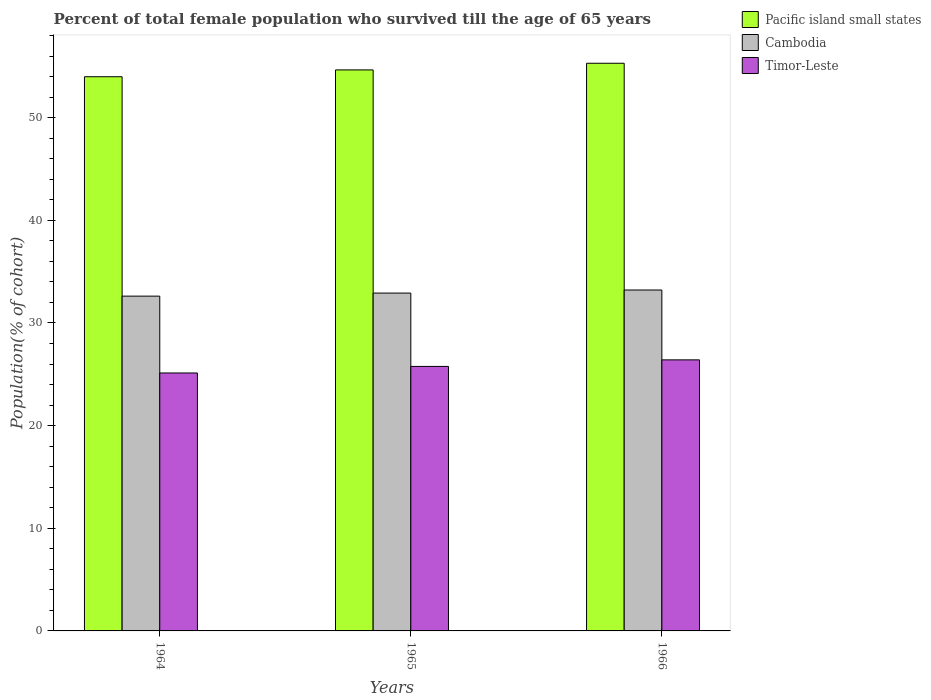How many different coloured bars are there?
Your answer should be compact. 3. How many groups of bars are there?
Make the answer very short. 3. Are the number of bars on each tick of the X-axis equal?
Give a very brief answer. Yes. How many bars are there on the 2nd tick from the left?
Make the answer very short. 3. What is the label of the 2nd group of bars from the left?
Offer a very short reply. 1965. What is the percentage of total female population who survived till the age of 65 years in Pacific island small states in 1964?
Provide a succinct answer. 53.99. Across all years, what is the maximum percentage of total female population who survived till the age of 65 years in Pacific island small states?
Your answer should be very brief. 55.3. Across all years, what is the minimum percentage of total female population who survived till the age of 65 years in Pacific island small states?
Your response must be concise. 53.99. In which year was the percentage of total female population who survived till the age of 65 years in Pacific island small states maximum?
Provide a succinct answer. 1966. In which year was the percentage of total female population who survived till the age of 65 years in Cambodia minimum?
Your answer should be compact. 1964. What is the total percentage of total female population who survived till the age of 65 years in Pacific island small states in the graph?
Your answer should be very brief. 163.94. What is the difference between the percentage of total female population who survived till the age of 65 years in Timor-Leste in 1965 and that in 1966?
Offer a very short reply. -0.64. What is the difference between the percentage of total female population who survived till the age of 65 years in Pacific island small states in 1965 and the percentage of total female population who survived till the age of 65 years in Cambodia in 1966?
Give a very brief answer. 21.44. What is the average percentage of total female population who survived till the age of 65 years in Timor-Leste per year?
Provide a short and direct response. 25.77. In the year 1966, what is the difference between the percentage of total female population who survived till the age of 65 years in Cambodia and percentage of total female population who survived till the age of 65 years in Pacific island small states?
Offer a terse response. -22.09. In how many years, is the percentage of total female population who survived till the age of 65 years in Timor-Leste greater than 44 %?
Your answer should be very brief. 0. What is the ratio of the percentage of total female population who survived till the age of 65 years in Cambodia in 1964 to that in 1965?
Your answer should be compact. 0.99. Is the percentage of total female population who survived till the age of 65 years in Cambodia in 1964 less than that in 1966?
Your answer should be very brief. Yes. What is the difference between the highest and the second highest percentage of total female population who survived till the age of 65 years in Cambodia?
Offer a terse response. 0.3. What is the difference between the highest and the lowest percentage of total female population who survived till the age of 65 years in Cambodia?
Give a very brief answer. 0.6. In how many years, is the percentage of total female population who survived till the age of 65 years in Cambodia greater than the average percentage of total female population who survived till the age of 65 years in Cambodia taken over all years?
Make the answer very short. 2. Is the sum of the percentage of total female population who survived till the age of 65 years in Cambodia in 1964 and 1965 greater than the maximum percentage of total female population who survived till the age of 65 years in Timor-Leste across all years?
Provide a short and direct response. Yes. What does the 3rd bar from the left in 1966 represents?
Provide a short and direct response. Timor-Leste. What does the 2nd bar from the right in 1966 represents?
Give a very brief answer. Cambodia. How many years are there in the graph?
Provide a short and direct response. 3. Does the graph contain any zero values?
Provide a succinct answer. No. Does the graph contain grids?
Provide a succinct answer. No. How many legend labels are there?
Give a very brief answer. 3. How are the legend labels stacked?
Offer a terse response. Vertical. What is the title of the graph?
Make the answer very short. Percent of total female population who survived till the age of 65 years. Does "Uruguay" appear as one of the legend labels in the graph?
Give a very brief answer. No. What is the label or title of the Y-axis?
Provide a short and direct response. Population(% of cohort). What is the Population(% of cohort) of Pacific island small states in 1964?
Provide a short and direct response. 53.99. What is the Population(% of cohort) in Cambodia in 1964?
Keep it short and to the point. 32.61. What is the Population(% of cohort) in Timor-Leste in 1964?
Keep it short and to the point. 25.13. What is the Population(% of cohort) in Pacific island small states in 1965?
Provide a short and direct response. 54.65. What is the Population(% of cohort) of Cambodia in 1965?
Offer a terse response. 32.91. What is the Population(% of cohort) in Timor-Leste in 1965?
Ensure brevity in your answer.  25.77. What is the Population(% of cohort) in Pacific island small states in 1966?
Provide a short and direct response. 55.3. What is the Population(% of cohort) in Cambodia in 1966?
Your response must be concise. 33.21. What is the Population(% of cohort) in Timor-Leste in 1966?
Offer a very short reply. 26.41. Across all years, what is the maximum Population(% of cohort) of Pacific island small states?
Make the answer very short. 55.3. Across all years, what is the maximum Population(% of cohort) in Cambodia?
Offer a very short reply. 33.21. Across all years, what is the maximum Population(% of cohort) of Timor-Leste?
Your answer should be compact. 26.41. Across all years, what is the minimum Population(% of cohort) of Pacific island small states?
Provide a short and direct response. 53.99. Across all years, what is the minimum Population(% of cohort) of Cambodia?
Offer a very short reply. 32.61. Across all years, what is the minimum Population(% of cohort) of Timor-Leste?
Make the answer very short. 25.13. What is the total Population(% of cohort) in Pacific island small states in the graph?
Ensure brevity in your answer.  163.94. What is the total Population(% of cohort) of Cambodia in the graph?
Provide a succinct answer. 98.74. What is the total Population(% of cohort) in Timor-Leste in the graph?
Your response must be concise. 77.3. What is the difference between the Population(% of cohort) of Pacific island small states in 1964 and that in 1965?
Offer a terse response. -0.66. What is the difference between the Population(% of cohort) of Cambodia in 1964 and that in 1965?
Offer a terse response. -0.3. What is the difference between the Population(% of cohort) of Timor-Leste in 1964 and that in 1965?
Ensure brevity in your answer.  -0.64. What is the difference between the Population(% of cohort) of Pacific island small states in 1964 and that in 1966?
Give a very brief answer. -1.31. What is the difference between the Population(% of cohort) of Cambodia in 1964 and that in 1966?
Your answer should be compact. -0.6. What is the difference between the Population(% of cohort) of Timor-Leste in 1964 and that in 1966?
Provide a short and direct response. -1.28. What is the difference between the Population(% of cohort) in Pacific island small states in 1965 and that in 1966?
Ensure brevity in your answer.  -0.65. What is the difference between the Population(% of cohort) of Cambodia in 1965 and that in 1966?
Offer a very short reply. -0.3. What is the difference between the Population(% of cohort) in Timor-Leste in 1965 and that in 1966?
Your answer should be very brief. -0.64. What is the difference between the Population(% of cohort) in Pacific island small states in 1964 and the Population(% of cohort) in Cambodia in 1965?
Ensure brevity in your answer.  21.08. What is the difference between the Population(% of cohort) of Pacific island small states in 1964 and the Population(% of cohort) of Timor-Leste in 1965?
Your response must be concise. 28.22. What is the difference between the Population(% of cohort) of Cambodia in 1964 and the Population(% of cohort) of Timor-Leste in 1965?
Give a very brief answer. 6.85. What is the difference between the Population(% of cohort) of Pacific island small states in 1964 and the Population(% of cohort) of Cambodia in 1966?
Your response must be concise. 20.78. What is the difference between the Population(% of cohort) of Pacific island small states in 1964 and the Population(% of cohort) of Timor-Leste in 1966?
Ensure brevity in your answer.  27.58. What is the difference between the Population(% of cohort) of Cambodia in 1964 and the Population(% of cohort) of Timor-Leste in 1966?
Give a very brief answer. 6.21. What is the difference between the Population(% of cohort) of Pacific island small states in 1965 and the Population(% of cohort) of Cambodia in 1966?
Your response must be concise. 21.44. What is the difference between the Population(% of cohort) in Pacific island small states in 1965 and the Population(% of cohort) in Timor-Leste in 1966?
Your response must be concise. 28.25. What is the difference between the Population(% of cohort) of Cambodia in 1965 and the Population(% of cohort) of Timor-Leste in 1966?
Keep it short and to the point. 6.51. What is the average Population(% of cohort) of Pacific island small states per year?
Provide a succinct answer. 54.65. What is the average Population(% of cohort) in Cambodia per year?
Your answer should be very brief. 32.91. What is the average Population(% of cohort) of Timor-Leste per year?
Provide a short and direct response. 25.77. In the year 1964, what is the difference between the Population(% of cohort) in Pacific island small states and Population(% of cohort) in Cambodia?
Your answer should be very brief. 21.38. In the year 1964, what is the difference between the Population(% of cohort) of Pacific island small states and Population(% of cohort) of Timor-Leste?
Offer a terse response. 28.86. In the year 1964, what is the difference between the Population(% of cohort) of Cambodia and Population(% of cohort) of Timor-Leste?
Keep it short and to the point. 7.49. In the year 1965, what is the difference between the Population(% of cohort) in Pacific island small states and Population(% of cohort) in Cambodia?
Provide a short and direct response. 21.74. In the year 1965, what is the difference between the Population(% of cohort) in Pacific island small states and Population(% of cohort) in Timor-Leste?
Make the answer very short. 28.89. In the year 1965, what is the difference between the Population(% of cohort) in Cambodia and Population(% of cohort) in Timor-Leste?
Provide a short and direct response. 7.14. In the year 1966, what is the difference between the Population(% of cohort) of Pacific island small states and Population(% of cohort) of Cambodia?
Your response must be concise. 22.09. In the year 1966, what is the difference between the Population(% of cohort) of Pacific island small states and Population(% of cohort) of Timor-Leste?
Provide a succinct answer. 28.89. In the year 1966, what is the difference between the Population(% of cohort) of Cambodia and Population(% of cohort) of Timor-Leste?
Give a very brief answer. 6.8. What is the ratio of the Population(% of cohort) of Pacific island small states in 1964 to that in 1965?
Your answer should be very brief. 0.99. What is the ratio of the Population(% of cohort) in Cambodia in 1964 to that in 1965?
Ensure brevity in your answer.  0.99. What is the ratio of the Population(% of cohort) in Timor-Leste in 1964 to that in 1965?
Offer a very short reply. 0.98. What is the ratio of the Population(% of cohort) in Pacific island small states in 1964 to that in 1966?
Your response must be concise. 0.98. What is the ratio of the Population(% of cohort) of Cambodia in 1964 to that in 1966?
Your answer should be compact. 0.98. What is the ratio of the Population(% of cohort) in Timor-Leste in 1964 to that in 1966?
Give a very brief answer. 0.95. What is the ratio of the Population(% of cohort) of Pacific island small states in 1965 to that in 1966?
Your response must be concise. 0.99. What is the ratio of the Population(% of cohort) of Cambodia in 1965 to that in 1966?
Give a very brief answer. 0.99. What is the ratio of the Population(% of cohort) of Timor-Leste in 1965 to that in 1966?
Make the answer very short. 0.98. What is the difference between the highest and the second highest Population(% of cohort) of Pacific island small states?
Make the answer very short. 0.65. What is the difference between the highest and the second highest Population(% of cohort) in Cambodia?
Provide a succinct answer. 0.3. What is the difference between the highest and the second highest Population(% of cohort) in Timor-Leste?
Make the answer very short. 0.64. What is the difference between the highest and the lowest Population(% of cohort) in Pacific island small states?
Provide a succinct answer. 1.31. What is the difference between the highest and the lowest Population(% of cohort) in Cambodia?
Ensure brevity in your answer.  0.6. What is the difference between the highest and the lowest Population(% of cohort) in Timor-Leste?
Keep it short and to the point. 1.28. 